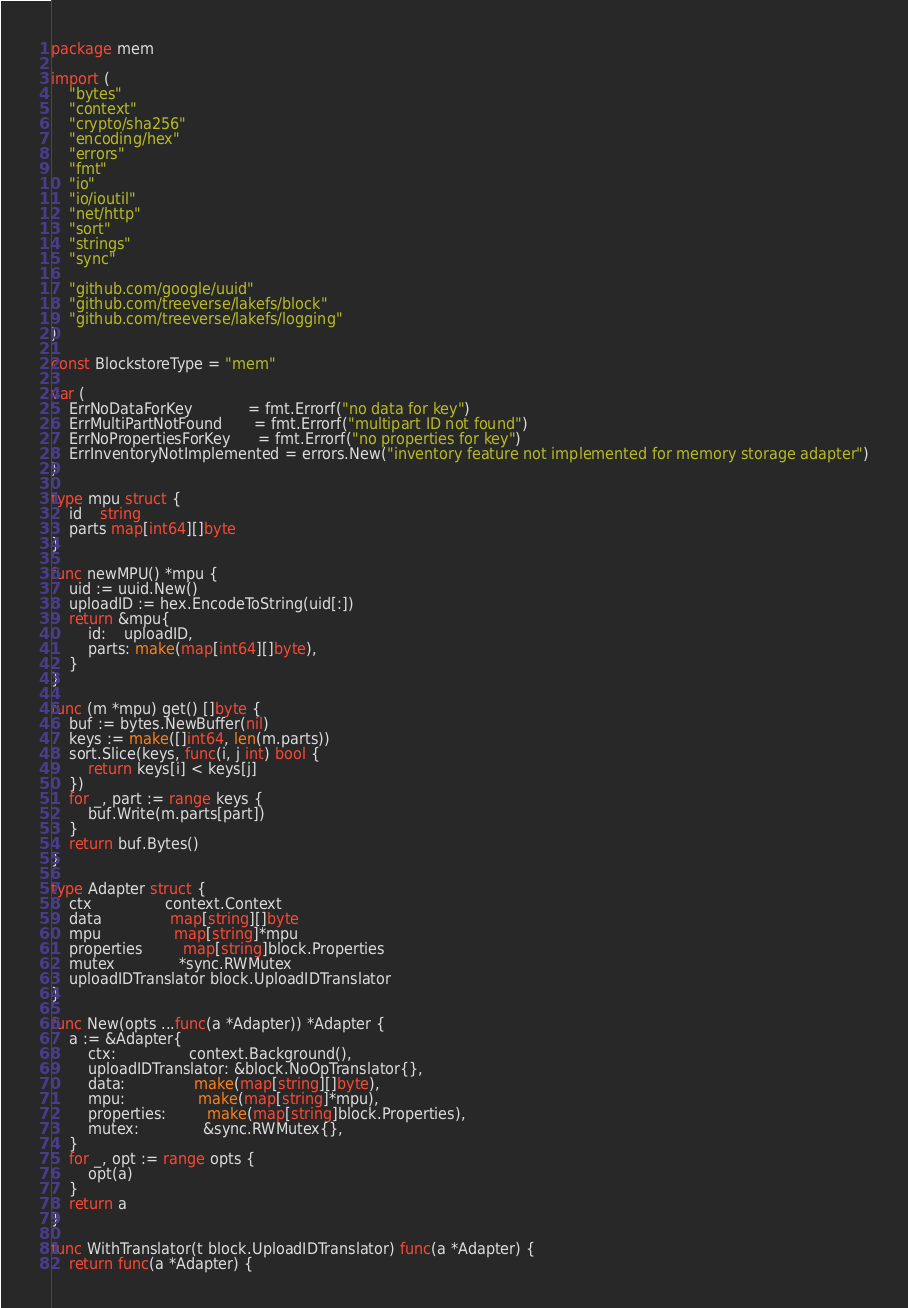Convert code to text. <code><loc_0><loc_0><loc_500><loc_500><_Go_>package mem

import (
	"bytes"
	"context"
	"crypto/sha256"
	"encoding/hex"
	"errors"
	"fmt"
	"io"
	"io/ioutil"
	"net/http"
	"sort"
	"strings"
	"sync"

	"github.com/google/uuid"
	"github.com/treeverse/lakefs/block"
	"github.com/treeverse/lakefs/logging"
)

const BlockstoreType = "mem"

var (
	ErrNoDataForKey            = fmt.Errorf("no data for key")
	ErrMultiPartNotFound       = fmt.Errorf("multipart ID not found")
	ErrNoPropertiesForKey      = fmt.Errorf("no properties for key")
	ErrInventoryNotImplemented = errors.New("inventory feature not implemented for memory storage adapter")
)

type mpu struct {
	id    string
	parts map[int64][]byte
}

func newMPU() *mpu {
	uid := uuid.New()
	uploadID := hex.EncodeToString(uid[:])
	return &mpu{
		id:    uploadID,
		parts: make(map[int64][]byte),
	}
}

func (m *mpu) get() []byte {
	buf := bytes.NewBuffer(nil)
	keys := make([]int64, len(m.parts))
	sort.Slice(keys, func(i, j int) bool {
		return keys[i] < keys[j]
	})
	for _, part := range keys {
		buf.Write(m.parts[part])
	}
	return buf.Bytes()
}

type Adapter struct {
	ctx                context.Context
	data               map[string][]byte
	mpu                map[string]*mpu
	properties         map[string]block.Properties
	mutex              *sync.RWMutex
	uploadIDTranslator block.UploadIDTranslator
}

func New(opts ...func(a *Adapter)) *Adapter {
	a := &Adapter{
		ctx:                context.Background(),
		uploadIDTranslator: &block.NoOpTranslator{},
		data:               make(map[string][]byte),
		mpu:                make(map[string]*mpu),
		properties:         make(map[string]block.Properties),
		mutex:              &sync.RWMutex{},
	}
	for _, opt := range opts {
		opt(a)
	}
	return a
}

func WithTranslator(t block.UploadIDTranslator) func(a *Adapter) {
	return func(a *Adapter) {</code> 